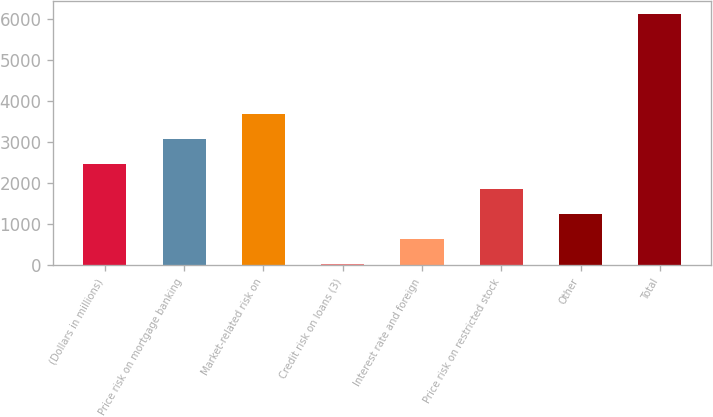<chart> <loc_0><loc_0><loc_500><loc_500><bar_chart><fcel>(Dollars in millions)<fcel>Price risk on mortgage banking<fcel>Market-related risk on<fcel>Credit risk on loans (3)<fcel>Interest rate and foreign<fcel>Price risk on restricted stock<fcel>Other<fcel>Total<nl><fcel>2464.8<fcel>3073.5<fcel>3682.2<fcel>30<fcel>638.7<fcel>1856.1<fcel>1247.4<fcel>6117<nl></chart> 